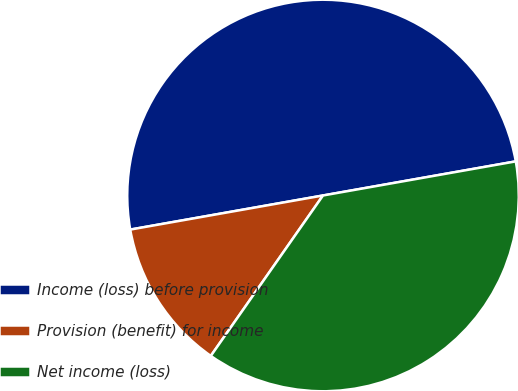<chart> <loc_0><loc_0><loc_500><loc_500><pie_chart><fcel>Income (loss) before provision<fcel>Provision (benefit) for income<fcel>Net income (loss)<nl><fcel>50.0%<fcel>12.5%<fcel>37.5%<nl></chart> 